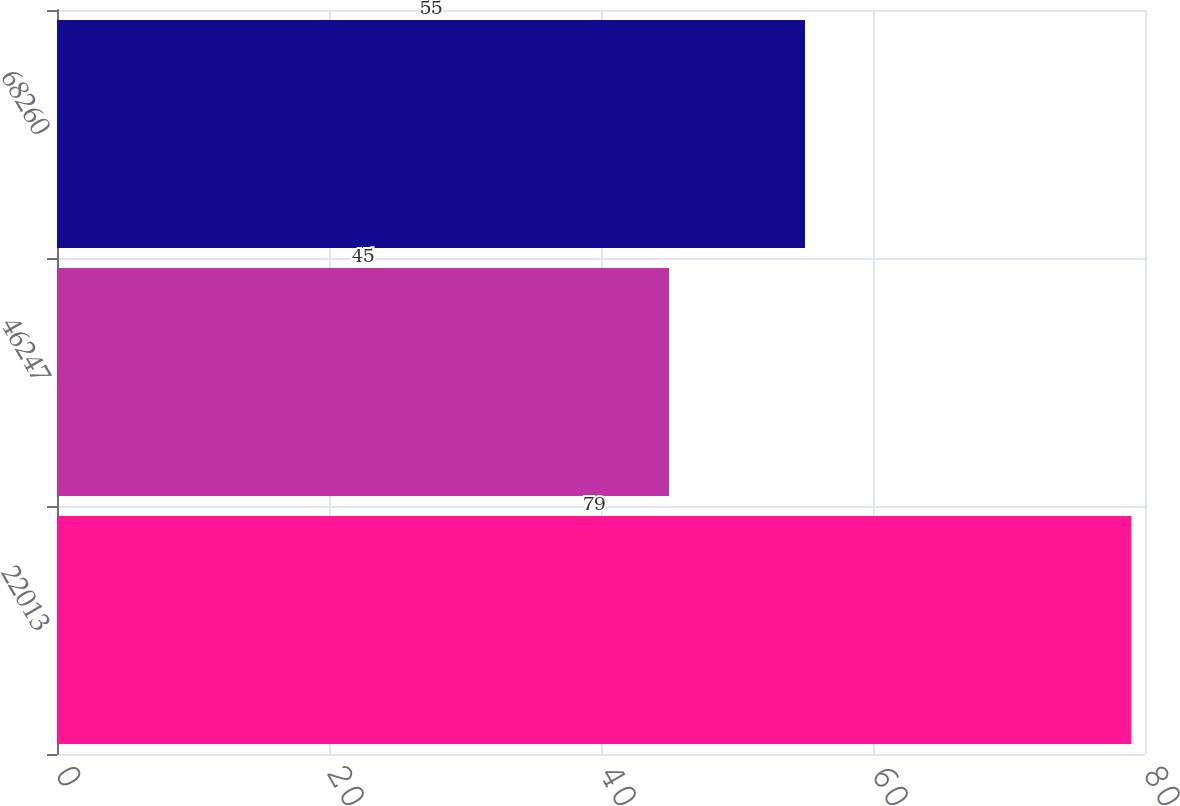<chart> <loc_0><loc_0><loc_500><loc_500><bar_chart><fcel>22013<fcel>46247<fcel>68260<nl><fcel>79<fcel>45<fcel>55<nl></chart> 